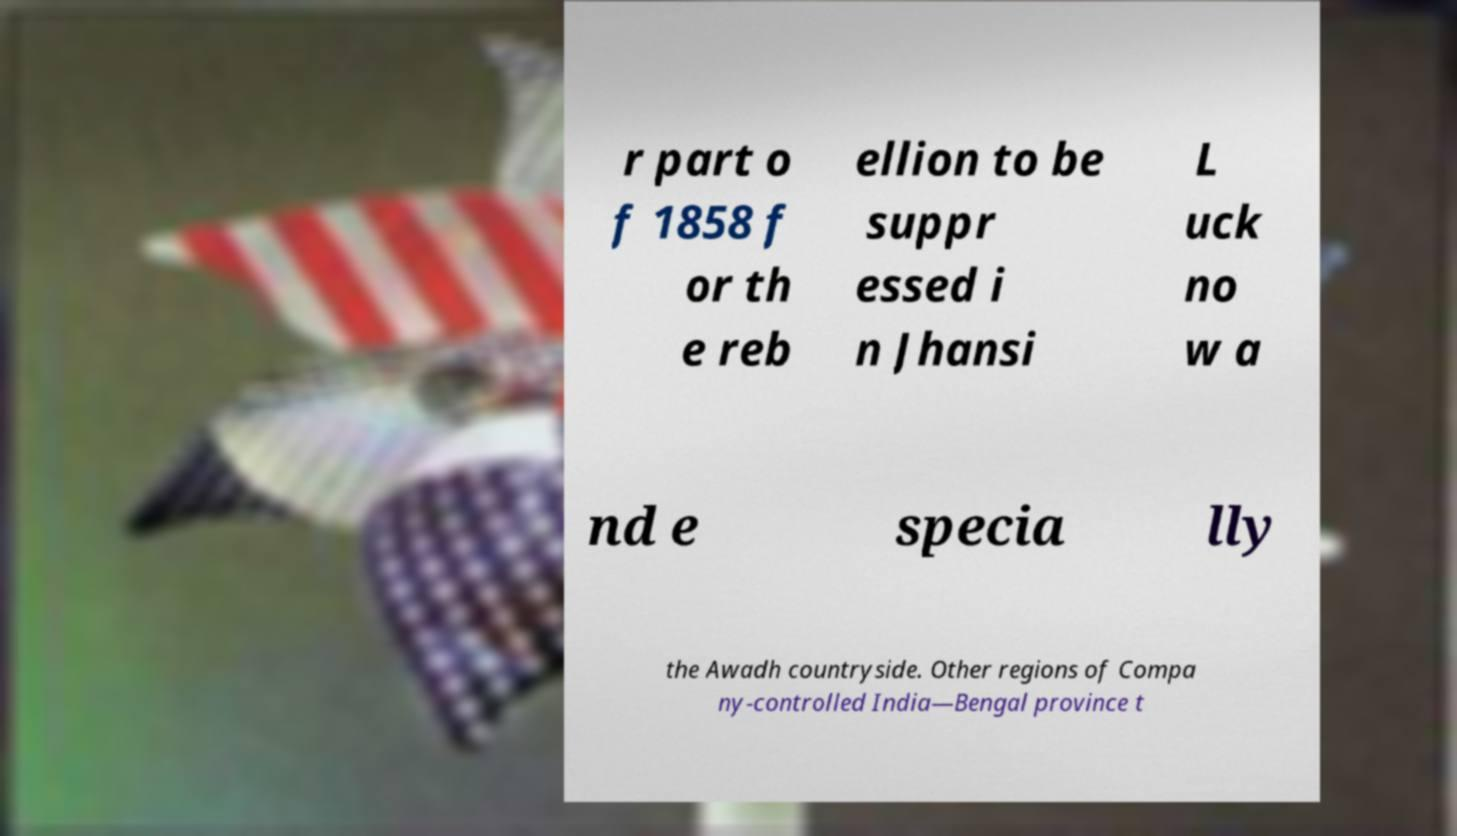Can you accurately transcribe the text from the provided image for me? r part o f 1858 f or th e reb ellion to be suppr essed i n Jhansi L uck no w a nd e specia lly the Awadh countryside. Other regions of Compa ny-controlled India—Bengal province t 